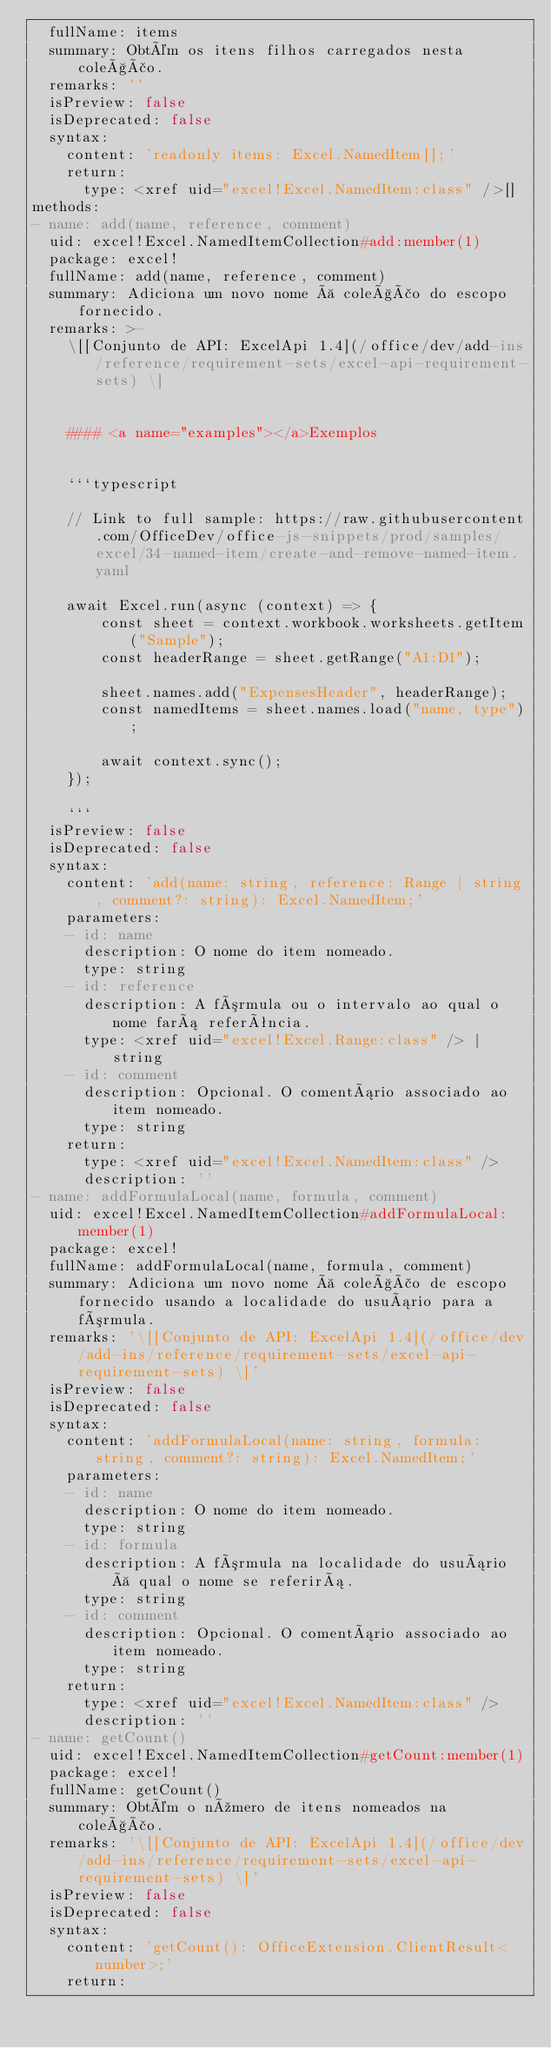Convert code to text. <code><loc_0><loc_0><loc_500><loc_500><_YAML_>  fullName: items
  summary: Obtém os itens filhos carregados nesta coleção.
  remarks: ''
  isPreview: false
  isDeprecated: false
  syntax:
    content: 'readonly items: Excel.NamedItem[];'
    return:
      type: <xref uid="excel!Excel.NamedItem:class" />[]
methods:
- name: add(name, reference, comment)
  uid: excel!Excel.NamedItemCollection#add:member(1)
  package: excel!
  fullName: add(name, reference, comment)
  summary: Adiciona um novo nome à coleção do escopo fornecido.
  remarks: >-
    \[[Conjunto de API: ExcelApi 1.4](/office/dev/add-ins/reference/requirement-sets/excel-api-requirement-sets) \]


    #### <a name="examples"></a>Exemplos


    ```typescript

    // Link to full sample: https://raw.githubusercontent.com/OfficeDev/office-js-snippets/prod/samples/excel/34-named-item/create-and-remove-named-item.yaml

    await Excel.run(async (context) => {
        const sheet = context.workbook.worksheets.getItem("Sample");
        const headerRange = sheet.getRange("A1:D1");

        sheet.names.add("ExpensesHeader", headerRange);
        const namedItems = sheet.names.load("name, type");

        await context.sync();
    });

    ```
  isPreview: false
  isDeprecated: false
  syntax:
    content: 'add(name: string, reference: Range | string, comment?: string): Excel.NamedItem;'
    parameters:
    - id: name
      description: O nome do item nomeado.
      type: string
    - id: reference
      description: A fórmula ou o intervalo ao qual o nome fará referência.
      type: <xref uid="excel!Excel.Range:class" /> | string
    - id: comment
      description: Opcional. O comentário associado ao item nomeado.
      type: string
    return:
      type: <xref uid="excel!Excel.NamedItem:class" />
      description: ''
- name: addFormulaLocal(name, formula, comment)
  uid: excel!Excel.NamedItemCollection#addFormulaLocal:member(1)
  package: excel!
  fullName: addFormulaLocal(name, formula, comment)
  summary: Adiciona um novo nome à coleção de escopo fornecido usando a localidade do usuário para a fórmula.
  remarks: '\[[Conjunto de API: ExcelApi 1.4](/office/dev/add-ins/reference/requirement-sets/excel-api-requirement-sets) \]'
  isPreview: false
  isDeprecated: false
  syntax:
    content: 'addFormulaLocal(name: string, formula: string, comment?: string): Excel.NamedItem;'
    parameters:
    - id: name
      description: O nome do item nomeado.
      type: string
    - id: formula
      description: A fórmula na localidade do usuário à qual o nome se referirá.
      type: string
    - id: comment
      description: Opcional. O comentário associado ao item nomeado.
      type: string
    return:
      type: <xref uid="excel!Excel.NamedItem:class" />
      description: ''
- name: getCount()
  uid: excel!Excel.NamedItemCollection#getCount:member(1)
  package: excel!
  fullName: getCount()
  summary: Obtém o número de itens nomeados na coleção.
  remarks: '\[[Conjunto de API: ExcelApi 1.4](/office/dev/add-ins/reference/requirement-sets/excel-api-requirement-sets) \]'
  isPreview: false
  isDeprecated: false
  syntax:
    content: 'getCount(): OfficeExtension.ClientResult<number>;'
    return:</code> 